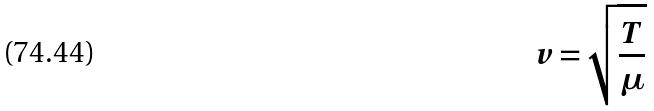<formula> <loc_0><loc_0><loc_500><loc_500>v = \sqrt { \frac { T } { \mu } }</formula> 